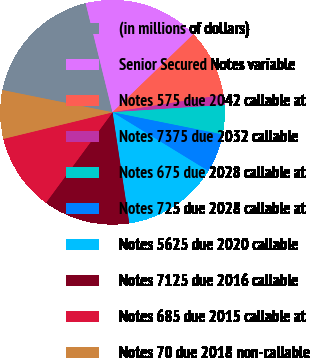Convert chart to OTSL. <chart><loc_0><loc_0><loc_500><loc_500><pie_chart><fcel>(in millions of dollars)<fcel>Senior Secured Notes variable<fcel>Notes 575 due 2042 callable at<fcel>Notes 7375 due 2032 callable<fcel>Notes 675 due 2028 callable at<fcel>Notes 725 due 2028 callable at<fcel>Notes 5625 due 2020 callable<fcel>Notes 7125 due 2016 callable<fcel>Notes 685 due 2015 callable at<fcel>Notes 70 due 2018 non-callable<nl><fcel>17.99%<fcel>16.62%<fcel>9.72%<fcel>1.46%<fcel>4.21%<fcel>5.59%<fcel>13.86%<fcel>12.48%<fcel>11.1%<fcel>6.97%<nl></chart> 